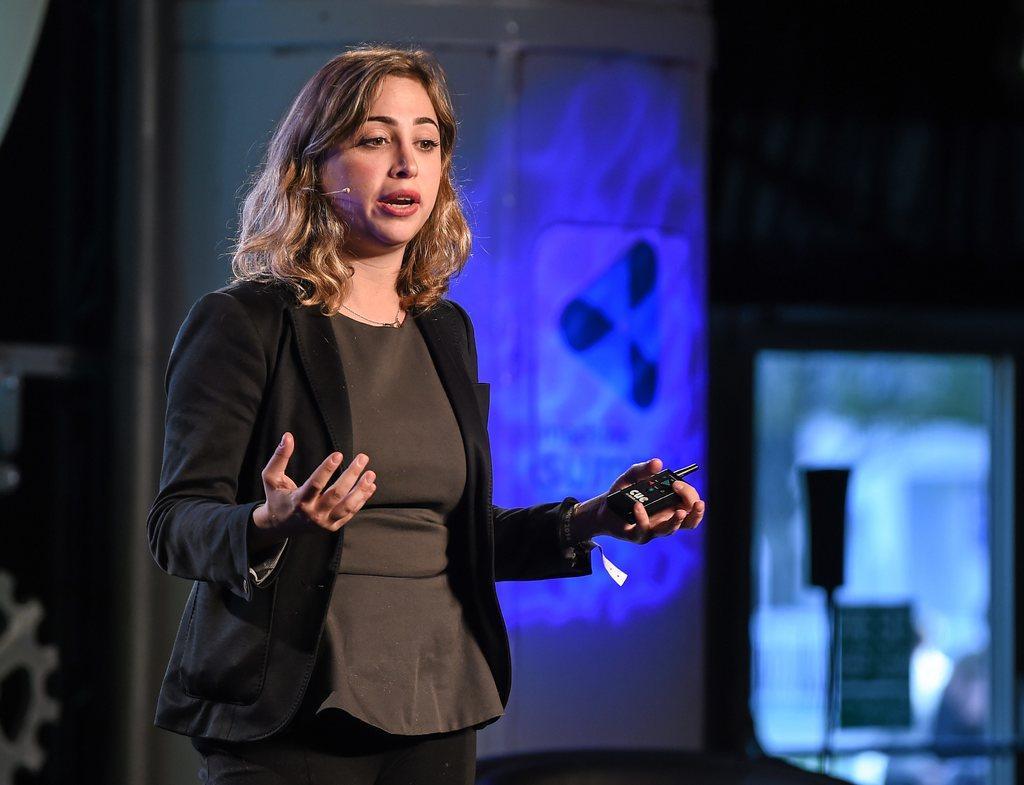How would you summarize this image in a sentence or two? In the picture there is a woman, she is standing and speaking something. She is wearing a black blazer, the background of the woman is blur. 